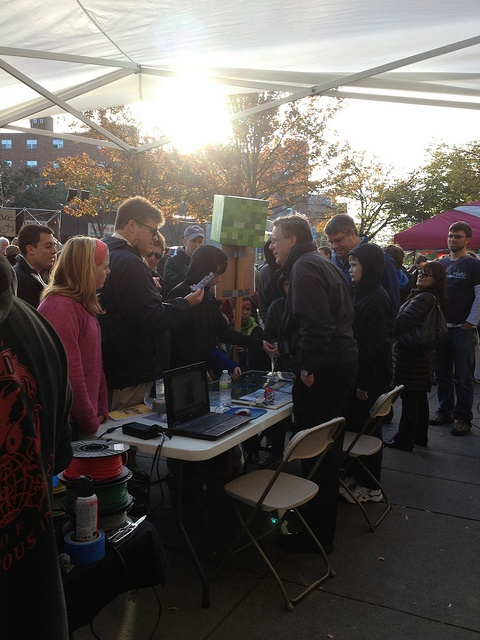Describe the objects in this image and their specific colors. I can see people in lightgray, black, maroon, and gray tones, people in lightgray, black, gray, and darkgray tones, dining table in lightgray, black, gray, and darkgray tones, people in lightgray, black, and gray tones, and chair in lightgray, black, and gray tones in this image. 